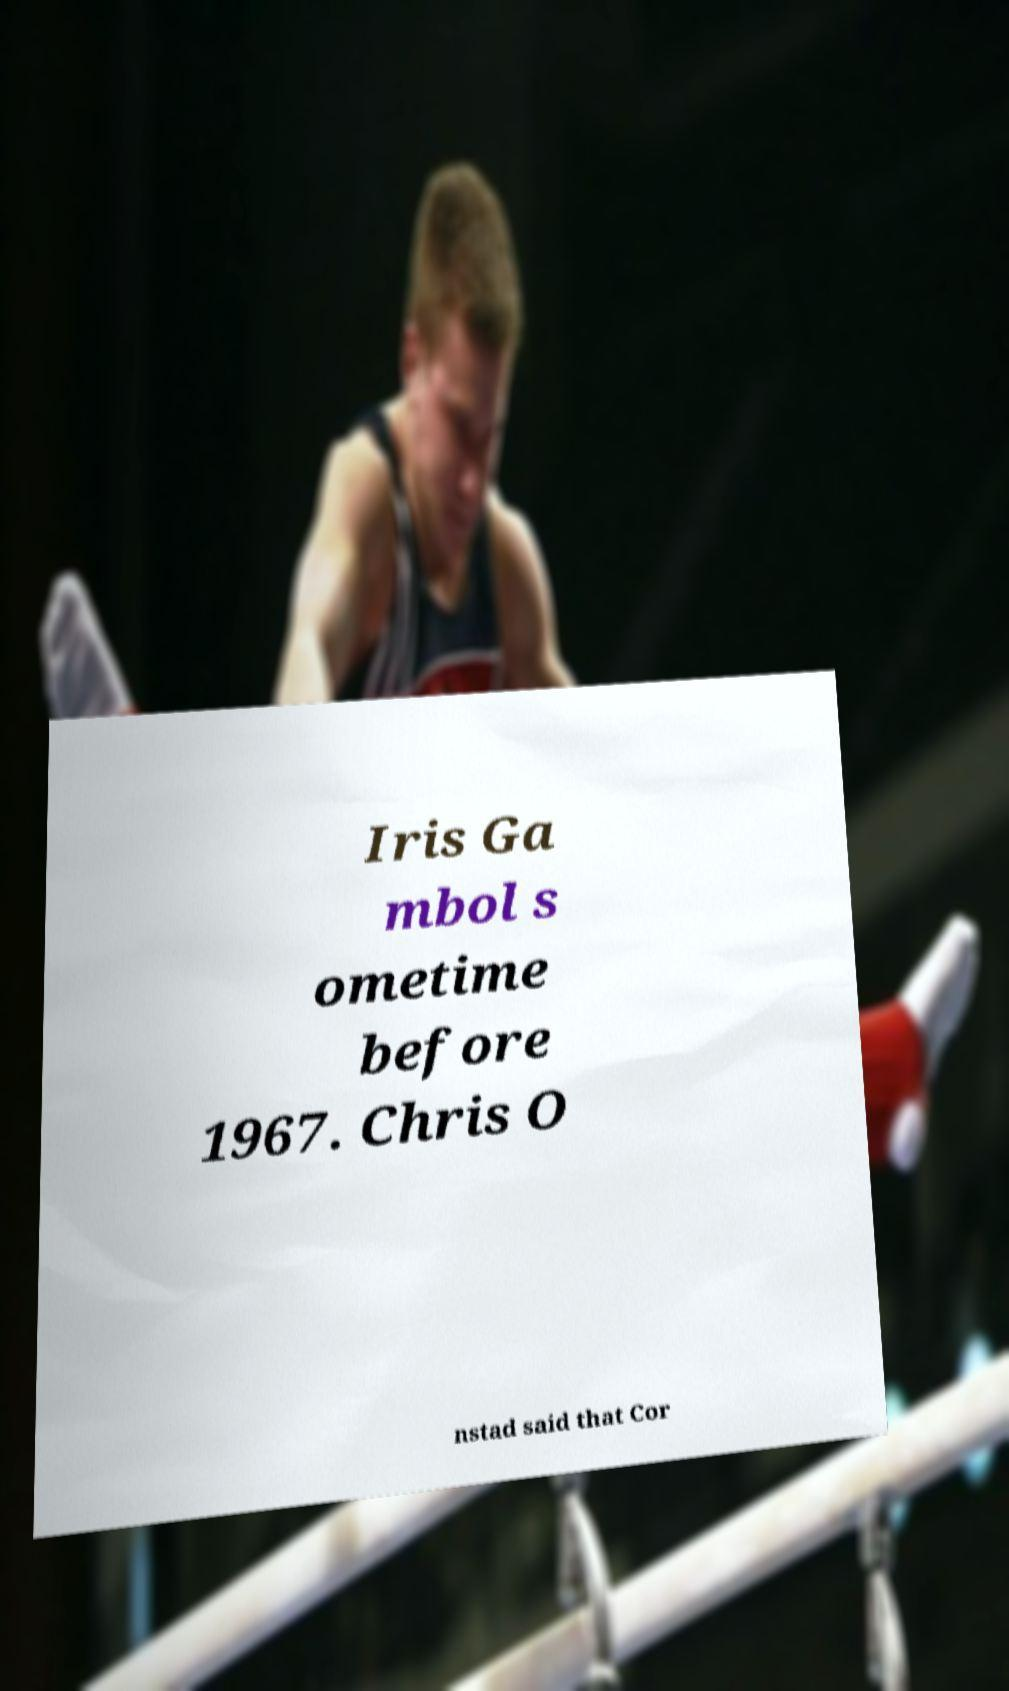I need the written content from this picture converted into text. Can you do that? Iris Ga mbol s ometime before 1967. Chris O nstad said that Cor 